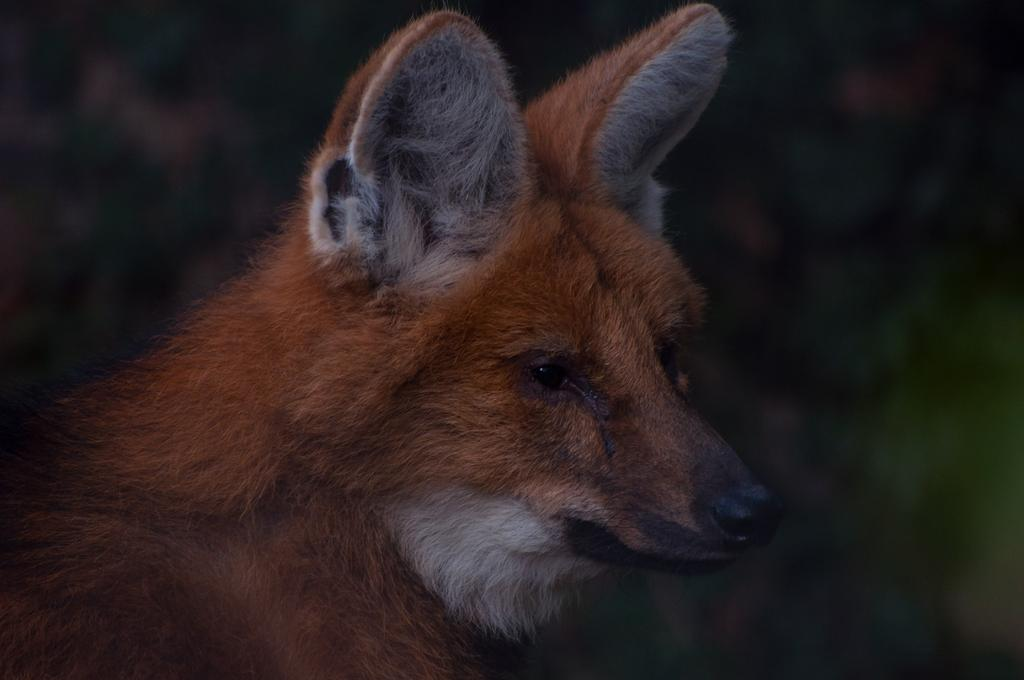What type of animal is the main subject in the image? There is a red fox in the image. Where is the red fox positioned in the image? The red fox is in the front of the image. Can you describe the background of the image? The background of the image is blurry. What type of door can be seen in the image? There is no door present in the image; it features a red fox in the front of a blurry background. What punishment is the red fox receiving in the image? There is no indication of any punishment being administered to the red fox in the image. 